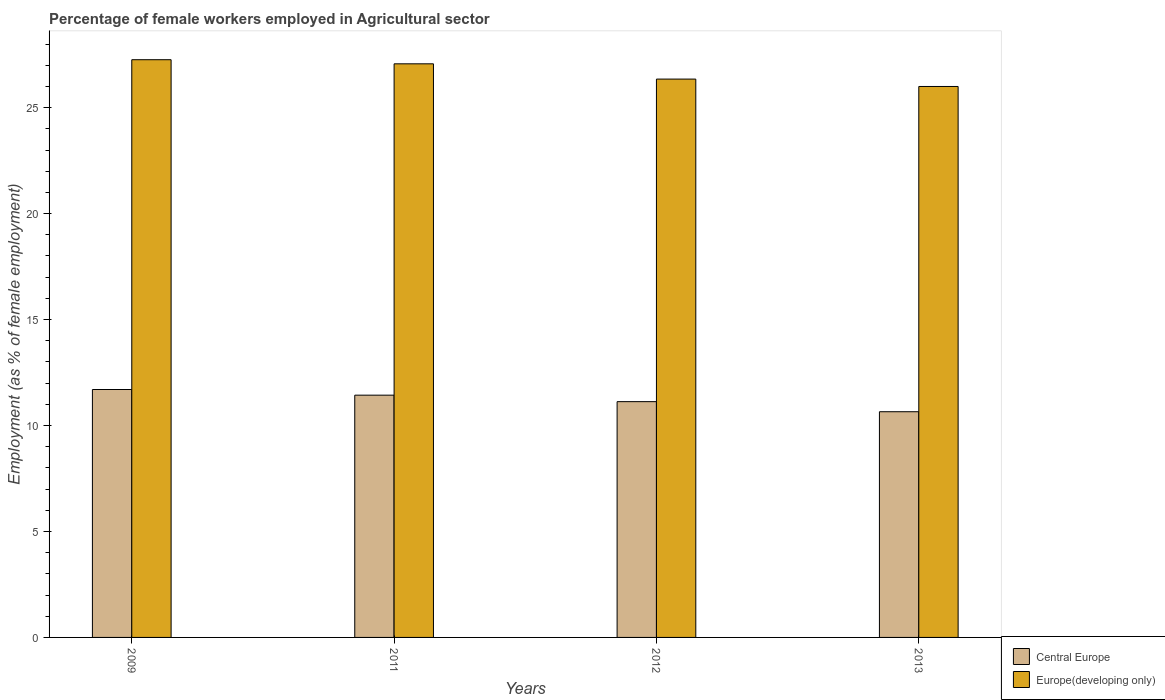How many groups of bars are there?
Your answer should be compact. 4. Are the number of bars per tick equal to the number of legend labels?
Keep it short and to the point. Yes. What is the label of the 3rd group of bars from the left?
Your answer should be very brief. 2012. In how many cases, is the number of bars for a given year not equal to the number of legend labels?
Your answer should be compact. 0. What is the percentage of females employed in Agricultural sector in Europe(developing only) in 2013?
Your response must be concise. 26. Across all years, what is the maximum percentage of females employed in Agricultural sector in Europe(developing only)?
Offer a very short reply. 27.26. Across all years, what is the minimum percentage of females employed in Agricultural sector in Central Europe?
Offer a very short reply. 10.65. What is the total percentage of females employed in Agricultural sector in Europe(developing only) in the graph?
Ensure brevity in your answer.  106.68. What is the difference between the percentage of females employed in Agricultural sector in Central Europe in 2011 and that in 2013?
Provide a short and direct response. 0.78. What is the difference between the percentage of females employed in Agricultural sector in Europe(developing only) in 2012 and the percentage of females employed in Agricultural sector in Central Europe in 2013?
Make the answer very short. 15.7. What is the average percentage of females employed in Agricultural sector in Europe(developing only) per year?
Provide a succinct answer. 26.67. In the year 2009, what is the difference between the percentage of females employed in Agricultural sector in Europe(developing only) and percentage of females employed in Agricultural sector in Central Europe?
Ensure brevity in your answer.  15.56. In how many years, is the percentage of females employed in Agricultural sector in Central Europe greater than 19 %?
Make the answer very short. 0. What is the ratio of the percentage of females employed in Agricultural sector in Europe(developing only) in 2009 to that in 2011?
Give a very brief answer. 1.01. Is the difference between the percentage of females employed in Agricultural sector in Europe(developing only) in 2011 and 2013 greater than the difference between the percentage of females employed in Agricultural sector in Central Europe in 2011 and 2013?
Make the answer very short. Yes. What is the difference between the highest and the second highest percentage of females employed in Agricultural sector in Central Europe?
Give a very brief answer. 0.27. What is the difference between the highest and the lowest percentage of females employed in Agricultural sector in Central Europe?
Your response must be concise. 1.05. Is the sum of the percentage of females employed in Agricultural sector in Europe(developing only) in 2011 and 2013 greater than the maximum percentage of females employed in Agricultural sector in Central Europe across all years?
Keep it short and to the point. Yes. What does the 1st bar from the left in 2009 represents?
Give a very brief answer. Central Europe. What does the 2nd bar from the right in 2009 represents?
Keep it short and to the point. Central Europe. How many bars are there?
Your response must be concise. 8. What is the difference between two consecutive major ticks on the Y-axis?
Make the answer very short. 5. Does the graph contain grids?
Provide a short and direct response. No. Where does the legend appear in the graph?
Offer a very short reply. Bottom right. How many legend labels are there?
Offer a very short reply. 2. How are the legend labels stacked?
Your response must be concise. Vertical. What is the title of the graph?
Make the answer very short. Percentage of female workers employed in Agricultural sector. Does "Algeria" appear as one of the legend labels in the graph?
Ensure brevity in your answer.  No. What is the label or title of the Y-axis?
Your answer should be compact. Employment (as % of female employment). What is the Employment (as % of female employment) in Central Europe in 2009?
Provide a succinct answer. 11.7. What is the Employment (as % of female employment) in Europe(developing only) in 2009?
Make the answer very short. 27.26. What is the Employment (as % of female employment) in Central Europe in 2011?
Make the answer very short. 11.43. What is the Employment (as % of female employment) in Europe(developing only) in 2011?
Offer a very short reply. 27.07. What is the Employment (as % of female employment) of Central Europe in 2012?
Keep it short and to the point. 11.13. What is the Employment (as % of female employment) of Europe(developing only) in 2012?
Your response must be concise. 26.35. What is the Employment (as % of female employment) in Central Europe in 2013?
Make the answer very short. 10.65. What is the Employment (as % of female employment) of Europe(developing only) in 2013?
Your answer should be compact. 26. Across all years, what is the maximum Employment (as % of female employment) of Central Europe?
Make the answer very short. 11.7. Across all years, what is the maximum Employment (as % of female employment) of Europe(developing only)?
Make the answer very short. 27.26. Across all years, what is the minimum Employment (as % of female employment) in Central Europe?
Your answer should be very brief. 10.65. Across all years, what is the minimum Employment (as % of female employment) of Europe(developing only)?
Keep it short and to the point. 26. What is the total Employment (as % of female employment) in Central Europe in the graph?
Your answer should be very brief. 44.91. What is the total Employment (as % of female employment) of Europe(developing only) in the graph?
Make the answer very short. 106.68. What is the difference between the Employment (as % of female employment) in Central Europe in 2009 and that in 2011?
Make the answer very short. 0.27. What is the difference between the Employment (as % of female employment) in Europe(developing only) in 2009 and that in 2011?
Keep it short and to the point. 0.19. What is the difference between the Employment (as % of female employment) in Central Europe in 2009 and that in 2012?
Your answer should be compact. 0.57. What is the difference between the Employment (as % of female employment) of Europe(developing only) in 2009 and that in 2012?
Provide a short and direct response. 0.91. What is the difference between the Employment (as % of female employment) in Central Europe in 2009 and that in 2013?
Keep it short and to the point. 1.05. What is the difference between the Employment (as % of female employment) in Europe(developing only) in 2009 and that in 2013?
Give a very brief answer. 1.26. What is the difference between the Employment (as % of female employment) of Central Europe in 2011 and that in 2012?
Give a very brief answer. 0.31. What is the difference between the Employment (as % of female employment) in Europe(developing only) in 2011 and that in 2012?
Provide a short and direct response. 0.72. What is the difference between the Employment (as % of female employment) of Central Europe in 2011 and that in 2013?
Provide a succinct answer. 0.78. What is the difference between the Employment (as % of female employment) in Europe(developing only) in 2011 and that in 2013?
Your response must be concise. 1.07. What is the difference between the Employment (as % of female employment) in Central Europe in 2012 and that in 2013?
Ensure brevity in your answer.  0.48. What is the difference between the Employment (as % of female employment) of Europe(developing only) in 2012 and that in 2013?
Ensure brevity in your answer.  0.35. What is the difference between the Employment (as % of female employment) of Central Europe in 2009 and the Employment (as % of female employment) of Europe(developing only) in 2011?
Offer a terse response. -15.37. What is the difference between the Employment (as % of female employment) of Central Europe in 2009 and the Employment (as % of female employment) of Europe(developing only) in 2012?
Offer a terse response. -14.65. What is the difference between the Employment (as % of female employment) of Central Europe in 2009 and the Employment (as % of female employment) of Europe(developing only) in 2013?
Keep it short and to the point. -14.3. What is the difference between the Employment (as % of female employment) of Central Europe in 2011 and the Employment (as % of female employment) of Europe(developing only) in 2012?
Your answer should be very brief. -14.92. What is the difference between the Employment (as % of female employment) of Central Europe in 2011 and the Employment (as % of female employment) of Europe(developing only) in 2013?
Offer a very short reply. -14.57. What is the difference between the Employment (as % of female employment) in Central Europe in 2012 and the Employment (as % of female employment) in Europe(developing only) in 2013?
Provide a succinct answer. -14.87. What is the average Employment (as % of female employment) in Central Europe per year?
Your answer should be compact. 11.23. What is the average Employment (as % of female employment) of Europe(developing only) per year?
Give a very brief answer. 26.67. In the year 2009, what is the difference between the Employment (as % of female employment) in Central Europe and Employment (as % of female employment) in Europe(developing only)?
Provide a succinct answer. -15.56. In the year 2011, what is the difference between the Employment (as % of female employment) of Central Europe and Employment (as % of female employment) of Europe(developing only)?
Make the answer very short. -15.64. In the year 2012, what is the difference between the Employment (as % of female employment) of Central Europe and Employment (as % of female employment) of Europe(developing only)?
Give a very brief answer. -15.22. In the year 2013, what is the difference between the Employment (as % of female employment) of Central Europe and Employment (as % of female employment) of Europe(developing only)?
Give a very brief answer. -15.35. What is the ratio of the Employment (as % of female employment) in Central Europe in 2009 to that in 2011?
Your answer should be compact. 1.02. What is the ratio of the Employment (as % of female employment) of Europe(developing only) in 2009 to that in 2011?
Provide a short and direct response. 1.01. What is the ratio of the Employment (as % of female employment) in Central Europe in 2009 to that in 2012?
Give a very brief answer. 1.05. What is the ratio of the Employment (as % of female employment) of Europe(developing only) in 2009 to that in 2012?
Provide a succinct answer. 1.03. What is the ratio of the Employment (as % of female employment) in Central Europe in 2009 to that in 2013?
Provide a succinct answer. 1.1. What is the ratio of the Employment (as % of female employment) in Europe(developing only) in 2009 to that in 2013?
Provide a succinct answer. 1.05. What is the ratio of the Employment (as % of female employment) in Central Europe in 2011 to that in 2012?
Offer a very short reply. 1.03. What is the ratio of the Employment (as % of female employment) of Europe(developing only) in 2011 to that in 2012?
Your answer should be compact. 1.03. What is the ratio of the Employment (as % of female employment) of Central Europe in 2011 to that in 2013?
Provide a succinct answer. 1.07. What is the ratio of the Employment (as % of female employment) of Europe(developing only) in 2011 to that in 2013?
Offer a terse response. 1.04. What is the ratio of the Employment (as % of female employment) of Central Europe in 2012 to that in 2013?
Provide a succinct answer. 1.04. What is the ratio of the Employment (as % of female employment) of Europe(developing only) in 2012 to that in 2013?
Your response must be concise. 1.01. What is the difference between the highest and the second highest Employment (as % of female employment) in Central Europe?
Your answer should be compact. 0.27. What is the difference between the highest and the second highest Employment (as % of female employment) in Europe(developing only)?
Your answer should be compact. 0.19. What is the difference between the highest and the lowest Employment (as % of female employment) of Central Europe?
Your answer should be very brief. 1.05. What is the difference between the highest and the lowest Employment (as % of female employment) in Europe(developing only)?
Keep it short and to the point. 1.26. 